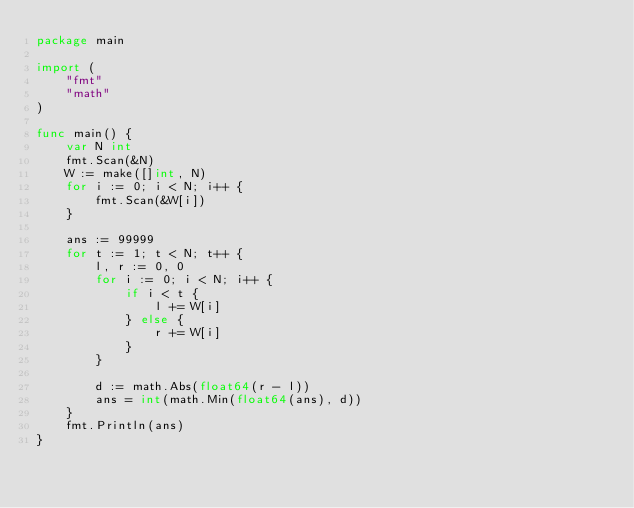<code> <loc_0><loc_0><loc_500><loc_500><_Go_>package main

import (
	"fmt"
	"math"
)

func main() {
	var N int
	fmt.Scan(&N)
	W := make([]int, N)
	for i := 0; i < N; i++ {
		fmt.Scan(&W[i])
	}

	ans := 99999
	for t := 1; t < N; t++ {
		l, r := 0, 0
		for i := 0; i < N; i++ {
			if i < t {
				l += W[i]
			} else {
				r += W[i]
			}
		}

		d := math.Abs(float64(r - l))
		ans = int(math.Min(float64(ans), d))
	}
	fmt.Println(ans)
}
</code> 